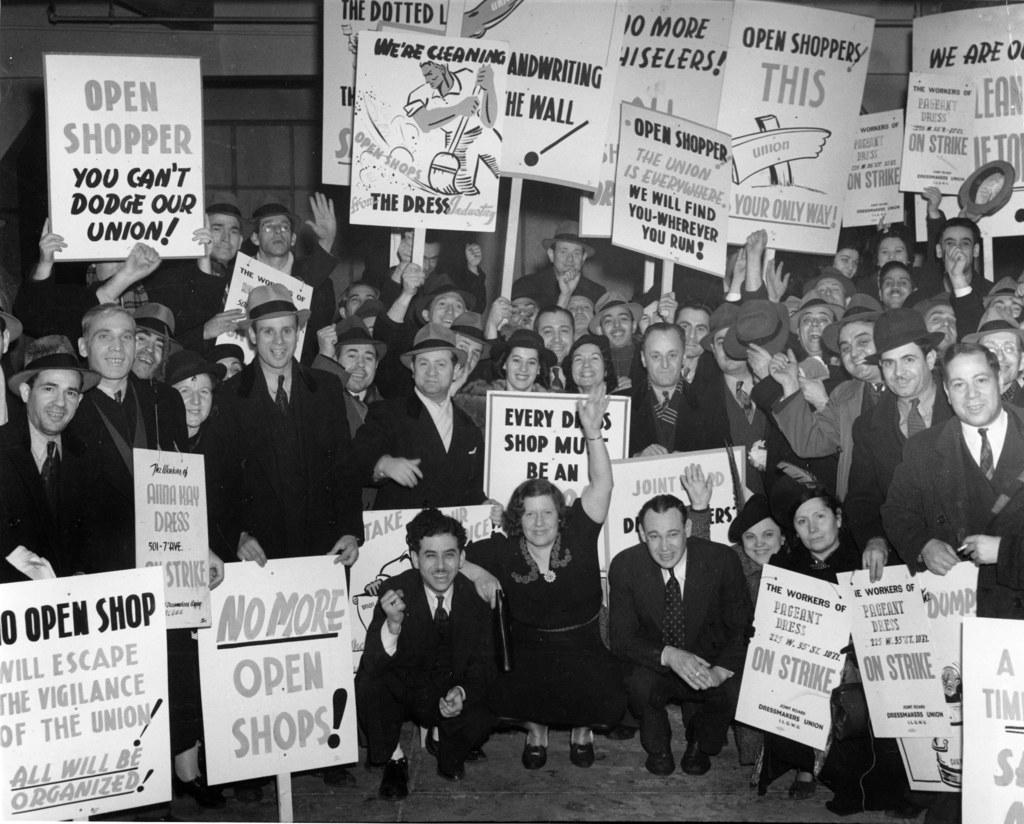What is the main subject of the image? The main subject of the image is a group of people. What are some of the people in the image holding? Some people in the image are holding placards. What type of clothing or accessory can be seen on some people in the image? Some people in the image are wearing caps. What color scheme is used in the image? The image is in black and white. Where is the crib located in the image? There is no crib present in the image. What type of swing can be seen in the image? There is no swing present in the image. 